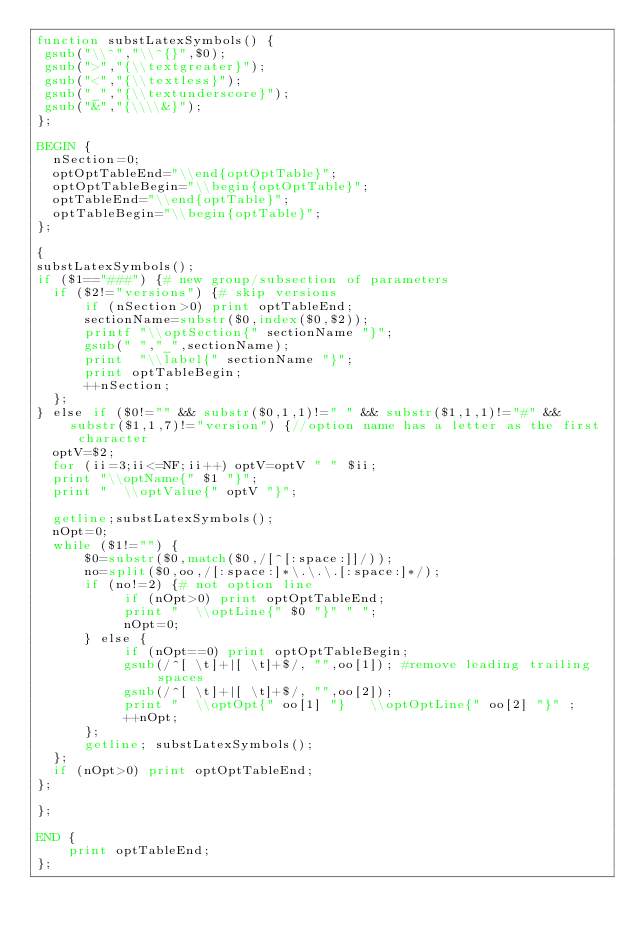Convert code to text. <code><loc_0><loc_0><loc_500><loc_500><_Awk_>function substLatexSymbols() {
 gsub("\\^","\\^{}",$0);
 gsub(">","{\\textgreater}");
 gsub("<","{\\textless}");
 gsub("_","{\\textunderscore}");
 gsub("&","{\\\\&}");
};

BEGIN {
  nSection=0;
  optOptTableEnd="\\end{optOptTable}";
  optOptTableBegin="\\begin{optOptTable}";
  optTableEnd="\\end{optTable}";
  optTableBegin="\\begin{optTable}";
};

{
substLatexSymbols();
if ($1=="###") {# new group/subsection of parameters
  if ($2!="versions") {# skip versions
      if (nSection>0) print optTableEnd;
      sectionName=substr($0,index($0,$2));
      printf "\\optSection{" sectionName "}";
      gsub(" ","_",sectionName);
      print  "\\label{" sectionName "}";
      print optTableBegin;
      ++nSection;
  };
} else if ($0!="" && substr($0,1,1)!=" " && substr($1,1,1)!="#" && substr($1,1,7)!="version") {//option name has a letter as the first character
  optV=$2; 
  for (ii=3;ii<=NF;ii++) optV=optV " " $ii;
  print "\\optName{" $1 "}";
  print "  \\optValue{" optV "}";

  getline;substLatexSymbols();
  nOpt=0;
  while ($1!="") {
      $0=substr($0,match($0,/[^[:space:]]/));
      no=split($0,oo,/[:space:]*\.\.\.[:space:]*/);
      if (no!=2) {# not option line
           if (nOpt>0) print optOptTableEnd;
           print "  \\optLine{" $0 "}" " ";
           nOpt=0;
      } else {
           if (nOpt==0) print optOptTableBegin;
           gsub(/^[ \t]+|[ \t]+$/, "",oo[1]); #remove leading trailing spaces
           gsub(/^[ \t]+|[ \t]+$/, "",oo[2]);
           print "  \\optOpt{" oo[1] "}   \\optOptLine{" oo[2] "}" ;
           ++nOpt;
      };
      getline; substLatexSymbols();
  };
  if (nOpt>0) print optOptTableEnd;
};

};

END {
    print optTableEnd;
};
</code> 